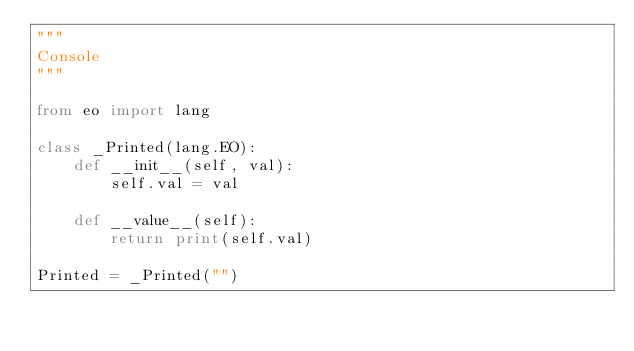<code> <loc_0><loc_0><loc_500><loc_500><_Python_>"""
Console
"""

from eo import lang

class _Printed(lang.EO):
    def __init__(self, val):
        self.val = val

    def __value__(self):
        return print(self.val)

Printed = _Printed("")
</code> 